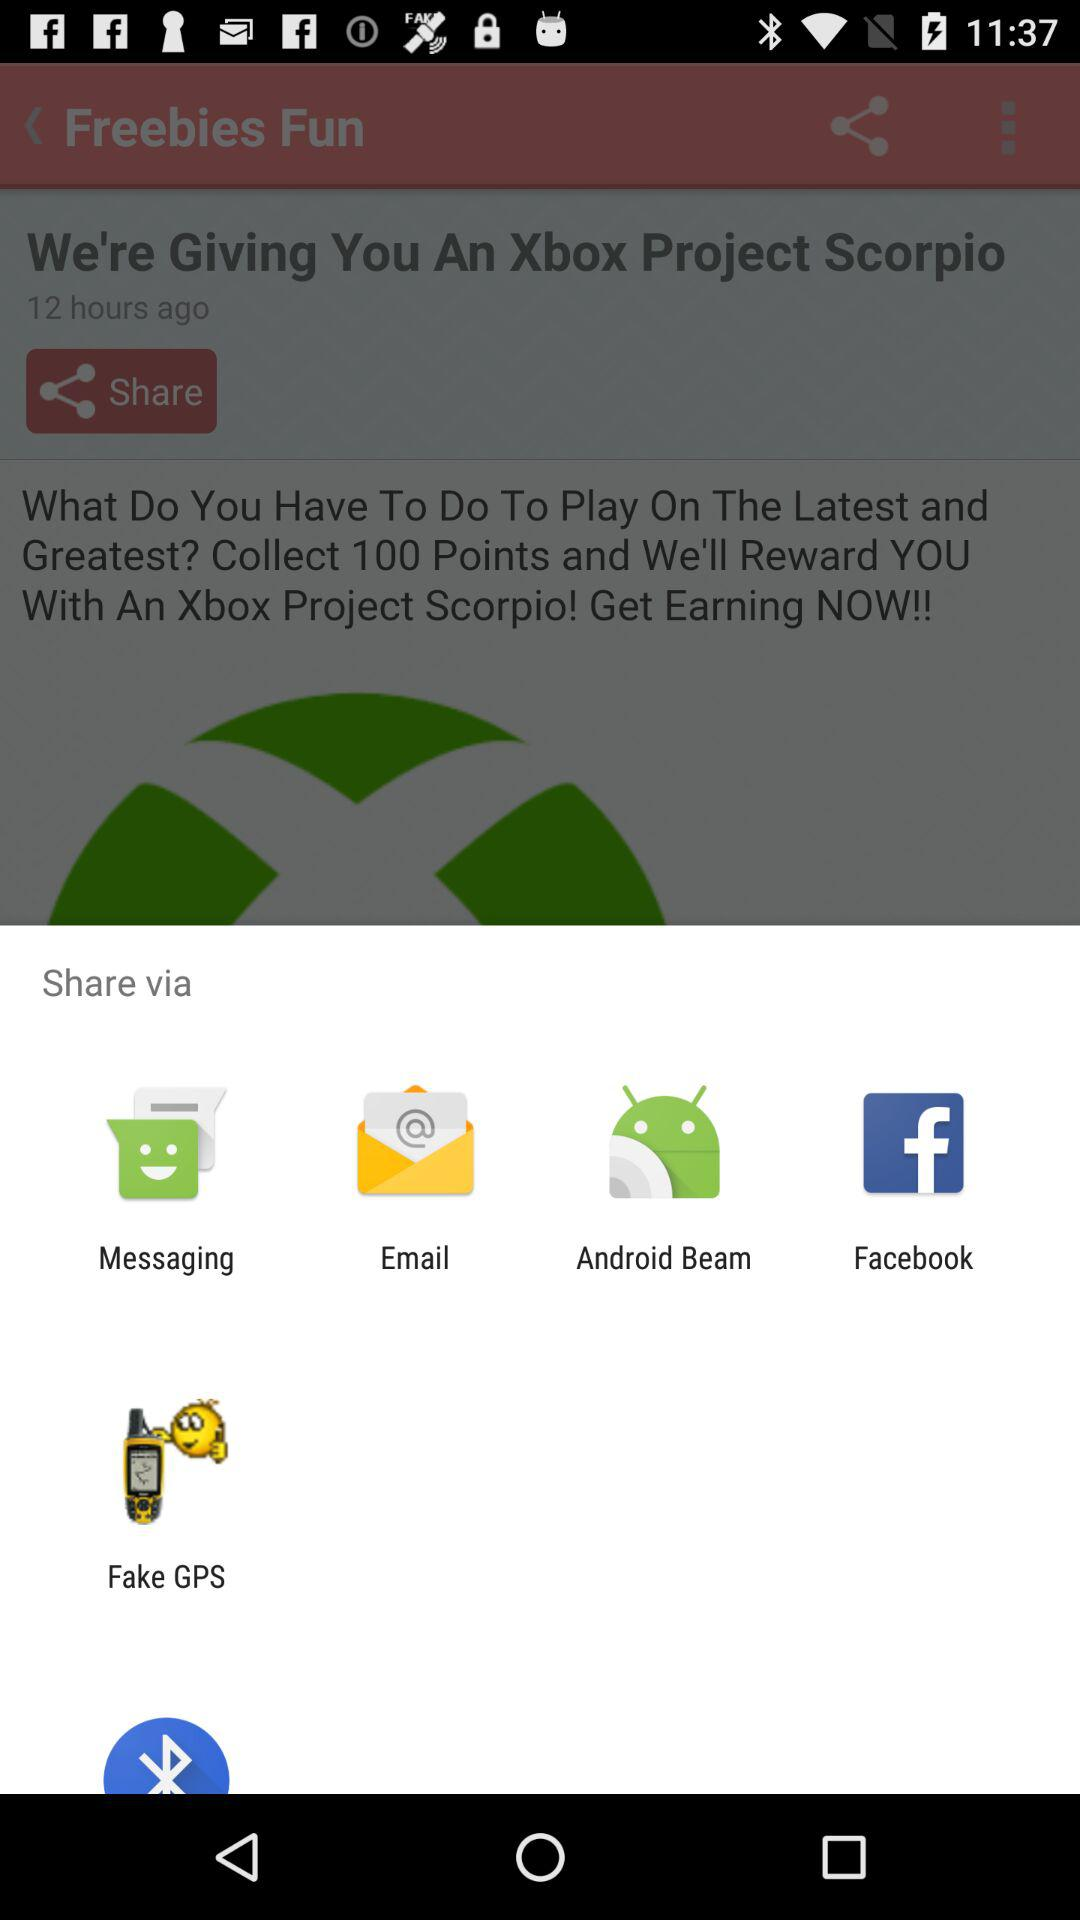What is the name of the application? The name of the application is "Freebies Fun". 